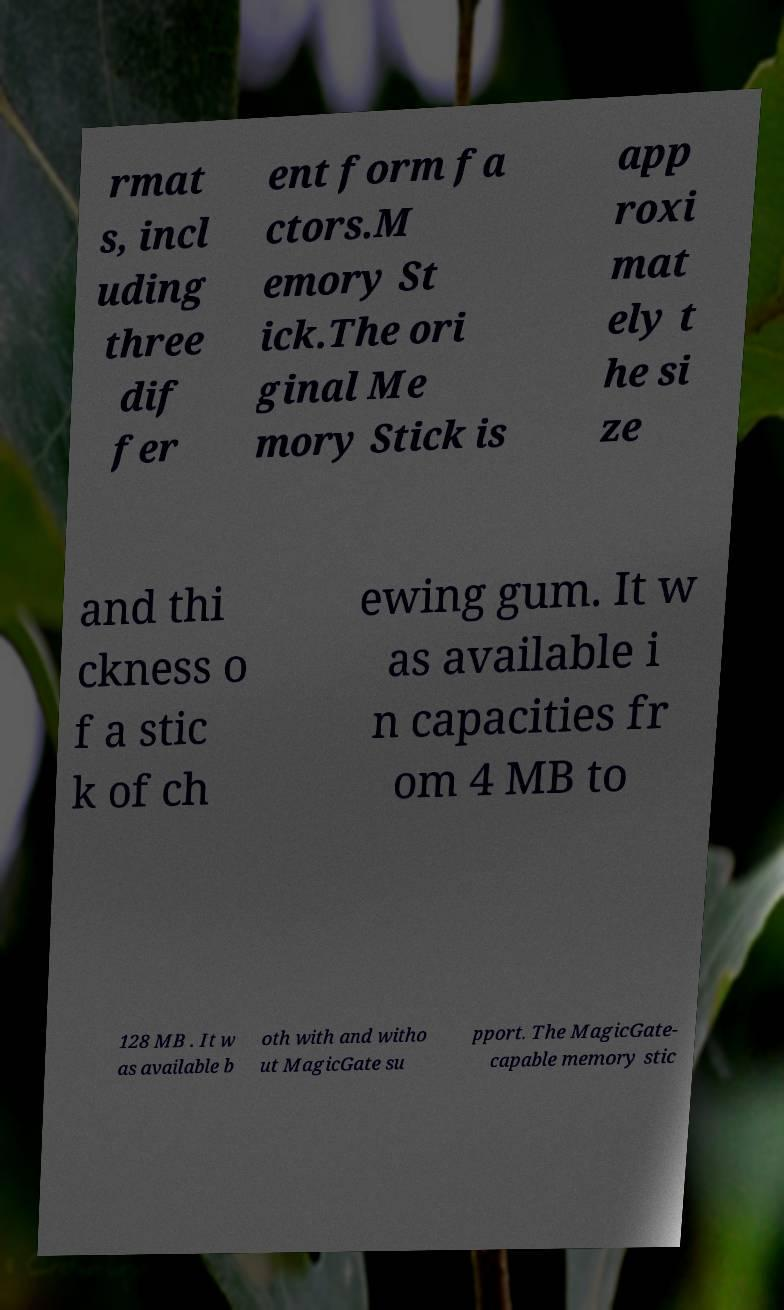I need the written content from this picture converted into text. Can you do that? rmat s, incl uding three dif fer ent form fa ctors.M emory St ick.The ori ginal Me mory Stick is app roxi mat ely t he si ze and thi ckness o f a stic k of ch ewing gum. It w as available i n capacities fr om 4 MB to 128 MB . It w as available b oth with and witho ut MagicGate su pport. The MagicGate- capable memory stic 